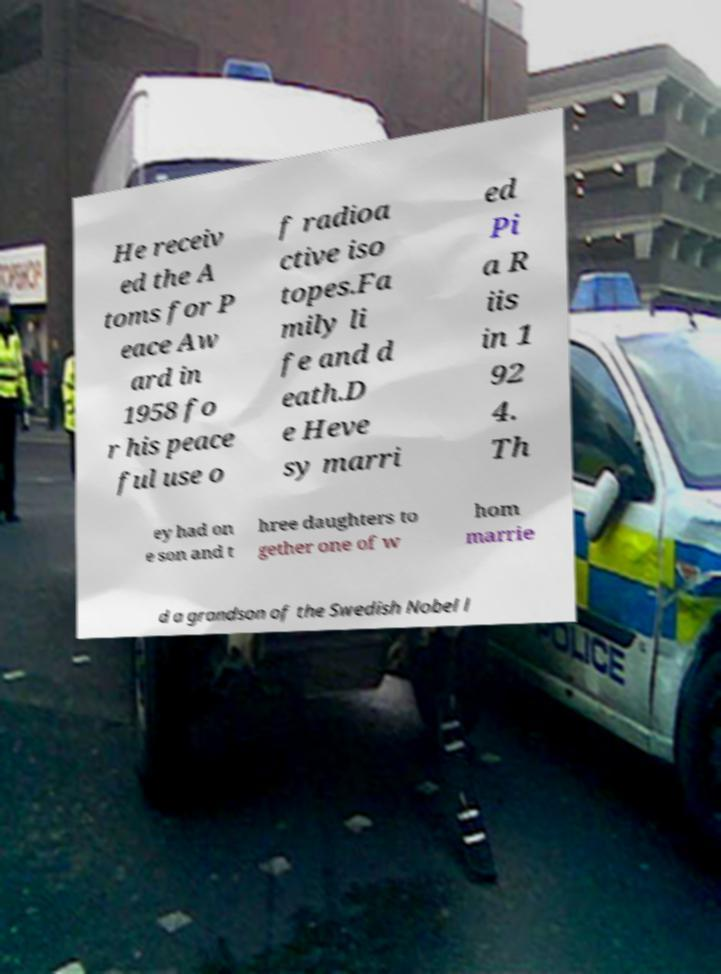Could you extract and type out the text from this image? He receiv ed the A toms for P eace Aw ard in 1958 fo r his peace ful use o f radioa ctive iso topes.Fa mily li fe and d eath.D e Heve sy marri ed Pi a R iis in 1 92 4. Th ey had on e son and t hree daughters to gether one of w hom marrie d a grandson of the Swedish Nobel l 